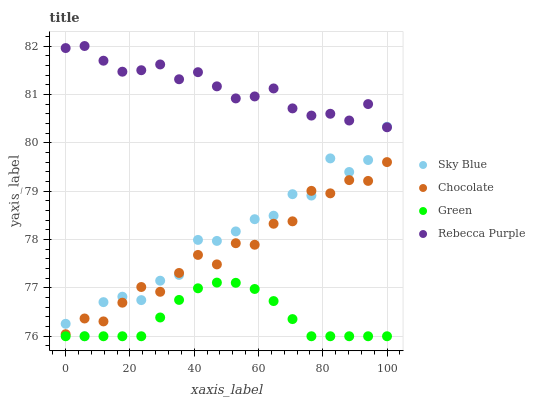Does Green have the minimum area under the curve?
Answer yes or no. Yes. Does Rebecca Purple have the maximum area under the curve?
Answer yes or no. Yes. Does Rebecca Purple have the minimum area under the curve?
Answer yes or no. No. Does Green have the maximum area under the curve?
Answer yes or no. No. Is Green the smoothest?
Answer yes or no. Yes. Is Sky Blue the roughest?
Answer yes or no. Yes. Is Rebecca Purple the smoothest?
Answer yes or no. No. Is Rebecca Purple the roughest?
Answer yes or no. No. Does Sky Blue have the lowest value?
Answer yes or no. Yes. Does Rebecca Purple have the lowest value?
Answer yes or no. No. Does Rebecca Purple have the highest value?
Answer yes or no. Yes. Does Green have the highest value?
Answer yes or no. No. Is Chocolate less than Rebecca Purple?
Answer yes or no. Yes. Is Rebecca Purple greater than Chocolate?
Answer yes or no. Yes. Does Green intersect Sky Blue?
Answer yes or no. Yes. Is Green less than Sky Blue?
Answer yes or no. No. Is Green greater than Sky Blue?
Answer yes or no. No. Does Chocolate intersect Rebecca Purple?
Answer yes or no. No. 